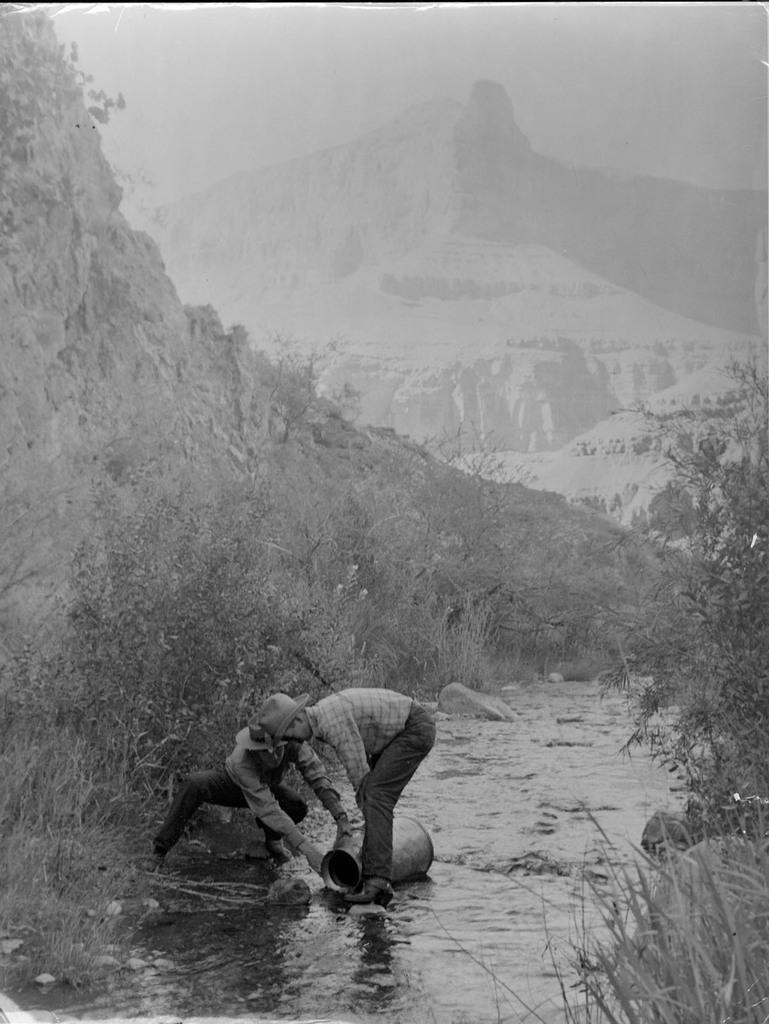Can you describe this image briefly? In this image, at the bottom three is a man, he wears a shirt, trouser, shoes, cap, he is holding a vessel and there is a person holding a vessel. In the middle there are plants, trees, waterstones. At the top there are hills, sky. 